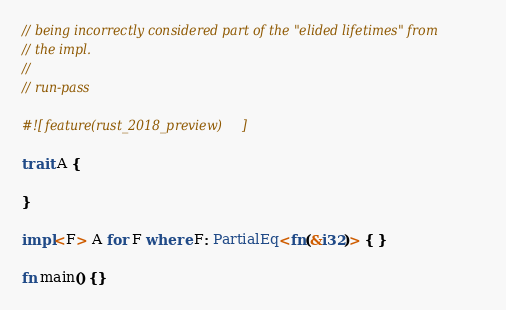Convert code to text. <code><loc_0><loc_0><loc_500><loc_500><_Rust_>// being incorrectly considered part of the "elided lifetimes" from
// the impl.
//
// run-pass

#![feature(rust_2018_preview)]

trait A {

}

impl<F> A for F where F: PartialEq<fn(&i32)> { }

fn main() {}
</code> 